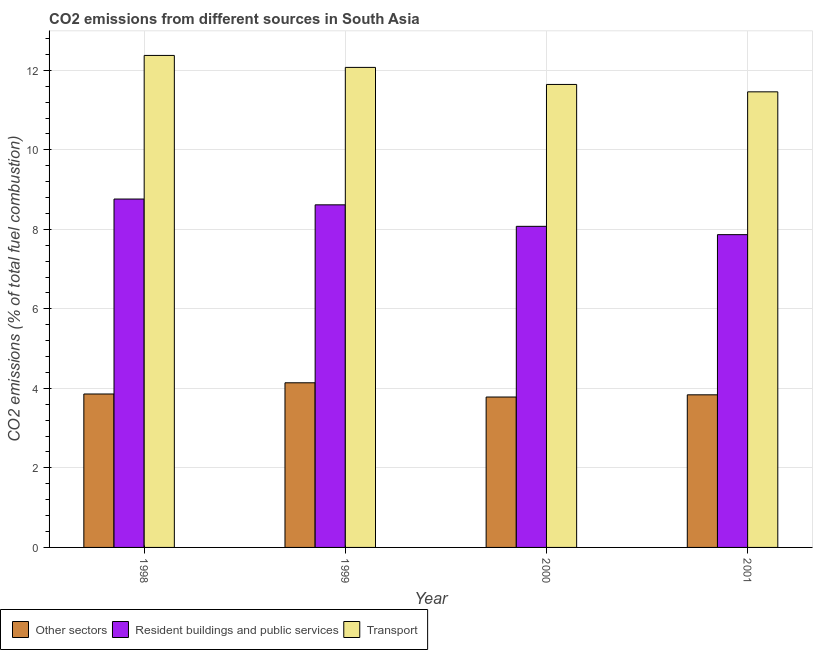How many different coloured bars are there?
Provide a short and direct response. 3. How many groups of bars are there?
Give a very brief answer. 4. Are the number of bars on each tick of the X-axis equal?
Keep it short and to the point. Yes. How many bars are there on the 1st tick from the right?
Give a very brief answer. 3. What is the label of the 2nd group of bars from the left?
Your answer should be very brief. 1999. In how many cases, is the number of bars for a given year not equal to the number of legend labels?
Keep it short and to the point. 0. What is the percentage of co2 emissions from transport in 1999?
Offer a very short reply. 12.07. Across all years, what is the maximum percentage of co2 emissions from transport?
Make the answer very short. 12.37. Across all years, what is the minimum percentage of co2 emissions from other sectors?
Make the answer very short. 3.78. In which year was the percentage of co2 emissions from other sectors maximum?
Keep it short and to the point. 1999. In which year was the percentage of co2 emissions from transport minimum?
Offer a very short reply. 2001. What is the total percentage of co2 emissions from resident buildings and public services in the graph?
Provide a short and direct response. 33.32. What is the difference between the percentage of co2 emissions from transport in 1998 and that in 2001?
Make the answer very short. 0.92. What is the difference between the percentage of co2 emissions from other sectors in 2001 and the percentage of co2 emissions from resident buildings and public services in 1998?
Provide a succinct answer. -0.02. What is the average percentage of co2 emissions from resident buildings and public services per year?
Give a very brief answer. 8.33. In the year 1998, what is the difference between the percentage of co2 emissions from other sectors and percentage of co2 emissions from resident buildings and public services?
Give a very brief answer. 0. What is the ratio of the percentage of co2 emissions from resident buildings and public services in 1998 to that in 2000?
Offer a very short reply. 1.09. Is the percentage of co2 emissions from other sectors in 2000 less than that in 2001?
Your response must be concise. Yes. Is the difference between the percentage of co2 emissions from other sectors in 1998 and 2000 greater than the difference between the percentage of co2 emissions from transport in 1998 and 2000?
Provide a short and direct response. No. What is the difference between the highest and the second highest percentage of co2 emissions from transport?
Provide a succinct answer. 0.3. What is the difference between the highest and the lowest percentage of co2 emissions from other sectors?
Your answer should be very brief. 0.36. In how many years, is the percentage of co2 emissions from other sectors greater than the average percentage of co2 emissions from other sectors taken over all years?
Make the answer very short. 1. What does the 3rd bar from the left in 2000 represents?
Your answer should be compact. Transport. What does the 3rd bar from the right in 1999 represents?
Keep it short and to the point. Other sectors. Is it the case that in every year, the sum of the percentage of co2 emissions from other sectors and percentage of co2 emissions from resident buildings and public services is greater than the percentage of co2 emissions from transport?
Provide a short and direct response. Yes. How many bars are there?
Keep it short and to the point. 12. Does the graph contain any zero values?
Make the answer very short. No. How many legend labels are there?
Your answer should be compact. 3. How are the legend labels stacked?
Ensure brevity in your answer.  Horizontal. What is the title of the graph?
Your response must be concise. CO2 emissions from different sources in South Asia. Does "Ages 15-64" appear as one of the legend labels in the graph?
Give a very brief answer. No. What is the label or title of the Y-axis?
Your response must be concise. CO2 emissions (% of total fuel combustion). What is the CO2 emissions (% of total fuel combustion) in Other sectors in 1998?
Offer a terse response. 3.86. What is the CO2 emissions (% of total fuel combustion) in Resident buildings and public services in 1998?
Ensure brevity in your answer.  8.76. What is the CO2 emissions (% of total fuel combustion) of Transport in 1998?
Offer a very short reply. 12.37. What is the CO2 emissions (% of total fuel combustion) in Other sectors in 1999?
Your response must be concise. 4.14. What is the CO2 emissions (% of total fuel combustion) in Resident buildings and public services in 1999?
Offer a terse response. 8.62. What is the CO2 emissions (% of total fuel combustion) in Transport in 1999?
Ensure brevity in your answer.  12.07. What is the CO2 emissions (% of total fuel combustion) in Other sectors in 2000?
Your answer should be very brief. 3.78. What is the CO2 emissions (% of total fuel combustion) in Resident buildings and public services in 2000?
Make the answer very short. 8.08. What is the CO2 emissions (% of total fuel combustion) in Transport in 2000?
Your response must be concise. 11.64. What is the CO2 emissions (% of total fuel combustion) in Other sectors in 2001?
Provide a succinct answer. 3.84. What is the CO2 emissions (% of total fuel combustion) in Resident buildings and public services in 2001?
Ensure brevity in your answer.  7.87. What is the CO2 emissions (% of total fuel combustion) of Transport in 2001?
Ensure brevity in your answer.  11.46. Across all years, what is the maximum CO2 emissions (% of total fuel combustion) in Other sectors?
Your answer should be very brief. 4.14. Across all years, what is the maximum CO2 emissions (% of total fuel combustion) of Resident buildings and public services?
Offer a terse response. 8.76. Across all years, what is the maximum CO2 emissions (% of total fuel combustion) of Transport?
Offer a very short reply. 12.37. Across all years, what is the minimum CO2 emissions (% of total fuel combustion) of Other sectors?
Provide a short and direct response. 3.78. Across all years, what is the minimum CO2 emissions (% of total fuel combustion) of Resident buildings and public services?
Your answer should be very brief. 7.87. Across all years, what is the minimum CO2 emissions (% of total fuel combustion) in Transport?
Your answer should be compact. 11.46. What is the total CO2 emissions (% of total fuel combustion) of Other sectors in the graph?
Keep it short and to the point. 15.62. What is the total CO2 emissions (% of total fuel combustion) in Resident buildings and public services in the graph?
Ensure brevity in your answer.  33.32. What is the total CO2 emissions (% of total fuel combustion) of Transport in the graph?
Offer a very short reply. 47.55. What is the difference between the CO2 emissions (% of total fuel combustion) in Other sectors in 1998 and that in 1999?
Make the answer very short. -0.28. What is the difference between the CO2 emissions (% of total fuel combustion) of Resident buildings and public services in 1998 and that in 1999?
Your answer should be compact. 0.15. What is the difference between the CO2 emissions (% of total fuel combustion) in Transport in 1998 and that in 1999?
Ensure brevity in your answer.  0.3. What is the difference between the CO2 emissions (% of total fuel combustion) in Other sectors in 1998 and that in 2000?
Keep it short and to the point. 0.08. What is the difference between the CO2 emissions (% of total fuel combustion) in Resident buildings and public services in 1998 and that in 2000?
Your answer should be very brief. 0.69. What is the difference between the CO2 emissions (% of total fuel combustion) of Transport in 1998 and that in 2000?
Provide a short and direct response. 0.73. What is the difference between the CO2 emissions (% of total fuel combustion) in Other sectors in 1998 and that in 2001?
Your answer should be very brief. 0.02. What is the difference between the CO2 emissions (% of total fuel combustion) of Resident buildings and public services in 1998 and that in 2001?
Provide a succinct answer. 0.9. What is the difference between the CO2 emissions (% of total fuel combustion) in Transport in 1998 and that in 2001?
Ensure brevity in your answer.  0.92. What is the difference between the CO2 emissions (% of total fuel combustion) in Other sectors in 1999 and that in 2000?
Provide a succinct answer. 0.36. What is the difference between the CO2 emissions (% of total fuel combustion) of Resident buildings and public services in 1999 and that in 2000?
Your answer should be compact. 0.54. What is the difference between the CO2 emissions (% of total fuel combustion) of Transport in 1999 and that in 2000?
Your answer should be very brief. 0.43. What is the difference between the CO2 emissions (% of total fuel combustion) in Other sectors in 1999 and that in 2001?
Offer a terse response. 0.3. What is the difference between the CO2 emissions (% of total fuel combustion) of Resident buildings and public services in 1999 and that in 2001?
Give a very brief answer. 0.75. What is the difference between the CO2 emissions (% of total fuel combustion) of Transport in 1999 and that in 2001?
Ensure brevity in your answer.  0.61. What is the difference between the CO2 emissions (% of total fuel combustion) of Other sectors in 2000 and that in 2001?
Offer a terse response. -0.06. What is the difference between the CO2 emissions (% of total fuel combustion) in Resident buildings and public services in 2000 and that in 2001?
Ensure brevity in your answer.  0.21. What is the difference between the CO2 emissions (% of total fuel combustion) of Transport in 2000 and that in 2001?
Give a very brief answer. 0.19. What is the difference between the CO2 emissions (% of total fuel combustion) in Other sectors in 1998 and the CO2 emissions (% of total fuel combustion) in Resident buildings and public services in 1999?
Provide a succinct answer. -4.76. What is the difference between the CO2 emissions (% of total fuel combustion) in Other sectors in 1998 and the CO2 emissions (% of total fuel combustion) in Transport in 1999?
Your answer should be compact. -8.21. What is the difference between the CO2 emissions (% of total fuel combustion) of Resident buildings and public services in 1998 and the CO2 emissions (% of total fuel combustion) of Transport in 1999?
Offer a terse response. -3.31. What is the difference between the CO2 emissions (% of total fuel combustion) in Other sectors in 1998 and the CO2 emissions (% of total fuel combustion) in Resident buildings and public services in 2000?
Ensure brevity in your answer.  -4.22. What is the difference between the CO2 emissions (% of total fuel combustion) of Other sectors in 1998 and the CO2 emissions (% of total fuel combustion) of Transport in 2000?
Provide a short and direct response. -7.79. What is the difference between the CO2 emissions (% of total fuel combustion) of Resident buildings and public services in 1998 and the CO2 emissions (% of total fuel combustion) of Transport in 2000?
Offer a terse response. -2.88. What is the difference between the CO2 emissions (% of total fuel combustion) in Other sectors in 1998 and the CO2 emissions (% of total fuel combustion) in Resident buildings and public services in 2001?
Offer a very short reply. -4.01. What is the difference between the CO2 emissions (% of total fuel combustion) of Other sectors in 1998 and the CO2 emissions (% of total fuel combustion) of Transport in 2001?
Make the answer very short. -7.6. What is the difference between the CO2 emissions (% of total fuel combustion) in Resident buildings and public services in 1998 and the CO2 emissions (% of total fuel combustion) in Transport in 2001?
Offer a very short reply. -2.7. What is the difference between the CO2 emissions (% of total fuel combustion) of Other sectors in 1999 and the CO2 emissions (% of total fuel combustion) of Resident buildings and public services in 2000?
Ensure brevity in your answer.  -3.93. What is the difference between the CO2 emissions (% of total fuel combustion) in Other sectors in 1999 and the CO2 emissions (% of total fuel combustion) in Transport in 2000?
Ensure brevity in your answer.  -7.5. What is the difference between the CO2 emissions (% of total fuel combustion) of Resident buildings and public services in 1999 and the CO2 emissions (% of total fuel combustion) of Transport in 2000?
Your answer should be compact. -3.03. What is the difference between the CO2 emissions (% of total fuel combustion) in Other sectors in 1999 and the CO2 emissions (% of total fuel combustion) in Resident buildings and public services in 2001?
Your answer should be compact. -3.73. What is the difference between the CO2 emissions (% of total fuel combustion) of Other sectors in 1999 and the CO2 emissions (% of total fuel combustion) of Transport in 2001?
Give a very brief answer. -7.32. What is the difference between the CO2 emissions (% of total fuel combustion) of Resident buildings and public services in 1999 and the CO2 emissions (% of total fuel combustion) of Transport in 2001?
Make the answer very short. -2.84. What is the difference between the CO2 emissions (% of total fuel combustion) in Other sectors in 2000 and the CO2 emissions (% of total fuel combustion) in Resident buildings and public services in 2001?
Your answer should be very brief. -4.08. What is the difference between the CO2 emissions (% of total fuel combustion) of Other sectors in 2000 and the CO2 emissions (% of total fuel combustion) of Transport in 2001?
Provide a short and direct response. -7.68. What is the difference between the CO2 emissions (% of total fuel combustion) in Resident buildings and public services in 2000 and the CO2 emissions (% of total fuel combustion) in Transport in 2001?
Offer a very short reply. -3.38. What is the average CO2 emissions (% of total fuel combustion) in Other sectors per year?
Keep it short and to the point. 3.91. What is the average CO2 emissions (% of total fuel combustion) in Resident buildings and public services per year?
Make the answer very short. 8.33. What is the average CO2 emissions (% of total fuel combustion) in Transport per year?
Make the answer very short. 11.89. In the year 1998, what is the difference between the CO2 emissions (% of total fuel combustion) in Other sectors and CO2 emissions (% of total fuel combustion) in Resident buildings and public services?
Offer a very short reply. -4.9. In the year 1998, what is the difference between the CO2 emissions (% of total fuel combustion) in Other sectors and CO2 emissions (% of total fuel combustion) in Transport?
Give a very brief answer. -8.52. In the year 1998, what is the difference between the CO2 emissions (% of total fuel combustion) in Resident buildings and public services and CO2 emissions (% of total fuel combustion) in Transport?
Your answer should be compact. -3.61. In the year 1999, what is the difference between the CO2 emissions (% of total fuel combustion) in Other sectors and CO2 emissions (% of total fuel combustion) in Resident buildings and public services?
Keep it short and to the point. -4.48. In the year 1999, what is the difference between the CO2 emissions (% of total fuel combustion) in Other sectors and CO2 emissions (% of total fuel combustion) in Transport?
Provide a short and direct response. -7.93. In the year 1999, what is the difference between the CO2 emissions (% of total fuel combustion) in Resident buildings and public services and CO2 emissions (% of total fuel combustion) in Transport?
Keep it short and to the point. -3.46. In the year 2000, what is the difference between the CO2 emissions (% of total fuel combustion) of Other sectors and CO2 emissions (% of total fuel combustion) of Resident buildings and public services?
Your response must be concise. -4.29. In the year 2000, what is the difference between the CO2 emissions (% of total fuel combustion) of Other sectors and CO2 emissions (% of total fuel combustion) of Transport?
Provide a short and direct response. -7.86. In the year 2000, what is the difference between the CO2 emissions (% of total fuel combustion) in Resident buildings and public services and CO2 emissions (% of total fuel combustion) in Transport?
Your answer should be very brief. -3.57. In the year 2001, what is the difference between the CO2 emissions (% of total fuel combustion) in Other sectors and CO2 emissions (% of total fuel combustion) in Resident buildings and public services?
Your response must be concise. -4.03. In the year 2001, what is the difference between the CO2 emissions (% of total fuel combustion) in Other sectors and CO2 emissions (% of total fuel combustion) in Transport?
Give a very brief answer. -7.62. In the year 2001, what is the difference between the CO2 emissions (% of total fuel combustion) of Resident buildings and public services and CO2 emissions (% of total fuel combustion) of Transport?
Offer a terse response. -3.59. What is the ratio of the CO2 emissions (% of total fuel combustion) in Other sectors in 1998 to that in 1999?
Your answer should be very brief. 0.93. What is the ratio of the CO2 emissions (% of total fuel combustion) of Resident buildings and public services in 1998 to that in 1999?
Provide a short and direct response. 1.02. What is the ratio of the CO2 emissions (% of total fuel combustion) in Transport in 1998 to that in 1999?
Offer a terse response. 1.02. What is the ratio of the CO2 emissions (% of total fuel combustion) of Other sectors in 1998 to that in 2000?
Provide a succinct answer. 1.02. What is the ratio of the CO2 emissions (% of total fuel combustion) of Resident buildings and public services in 1998 to that in 2000?
Your answer should be compact. 1.08. What is the ratio of the CO2 emissions (% of total fuel combustion) in Transport in 1998 to that in 2000?
Your answer should be very brief. 1.06. What is the ratio of the CO2 emissions (% of total fuel combustion) of Other sectors in 1998 to that in 2001?
Your answer should be compact. 1.01. What is the ratio of the CO2 emissions (% of total fuel combustion) in Resident buildings and public services in 1998 to that in 2001?
Ensure brevity in your answer.  1.11. What is the ratio of the CO2 emissions (% of total fuel combustion) in Transport in 1998 to that in 2001?
Provide a succinct answer. 1.08. What is the ratio of the CO2 emissions (% of total fuel combustion) of Other sectors in 1999 to that in 2000?
Your answer should be compact. 1.09. What is the ratio of the CO2 emissions (% of total fuel combustion) in Resident buildings and public services in 1999 to that in 2000?
Your answer should be very brief. 1.07. What is the ratio of the CO2 emissions (% of total fuel combustion) of Transport in 1999 to that in 2000?
Provide a succinct answer. 1.04. What is the ratio of the CO2 emissions (% of total fuel combustion) of Other sectors in 1999 to that in 2001?
Your answer should be very brief. 1.08. What is the ratio of the CO2 emissions (% of total fuel combustion) in Resident buildings and public services in 1999 to that in 2001?
Provide a short and direct response. 1.1. What is the ratio of the CO2 emissions (% of total fuel combustion) of Transport in 1999 to that in 2001?
Offer a very short reply. 1.05. What is the ratio of the CO2 emissions (% of total fuel combustion) of Other sectors in 2000 to that in 2001?
Offer a very short reply. 0.99. What is the ratio of the CO2 emissions (% of total fuel combustion) in Resident buildings and public services in 2000 to that in 2001?
Provide a short and direct response. 1.03. What is the ratio of the CO2 emissions (% of total fuel combustion) of Transport in 2000 to that in 2001?
Provide a short and direct response. 1.02. What is the difference between the highest and the second highest CO2 emissions (% of total fuel combustion) in Other sectors?
Give a very brief answer. 0.28. What is the difference between the highest and the second highest CO2 emissions (% of total fuel combustion) of Resident buildings and public services?
Offer a very short reply. 0.15. What is the difference between the highest and the second highest CO2 emissions (% of total fuel combustion) in Transport?
Provide a succinct answer. 0.3. What is the difference between the highest and the lowest CO2 emissions (% of total fuel combustion) of Other sectors?
Offer a terse response. 0.36. What is the difference between the highest and the lowest CO2 emissions (% of total fuel combustion) of Resident buildings and public services?
Ensure brevity in your answer.  0.9. What is the difference between the highest and the lowest CO2 emissions (% of total fuel combustion) of Transport?
Provide a succinct answer. 0.92. 